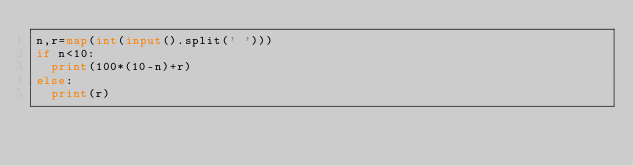Convert code to text. <code><loc_0><loc_0><loc_500><loc_500><_Python_>n,r=map(int(input().split(' ')))
if n<10:
  print(100*(10-n)+r)
else:
  print(r)</code> 